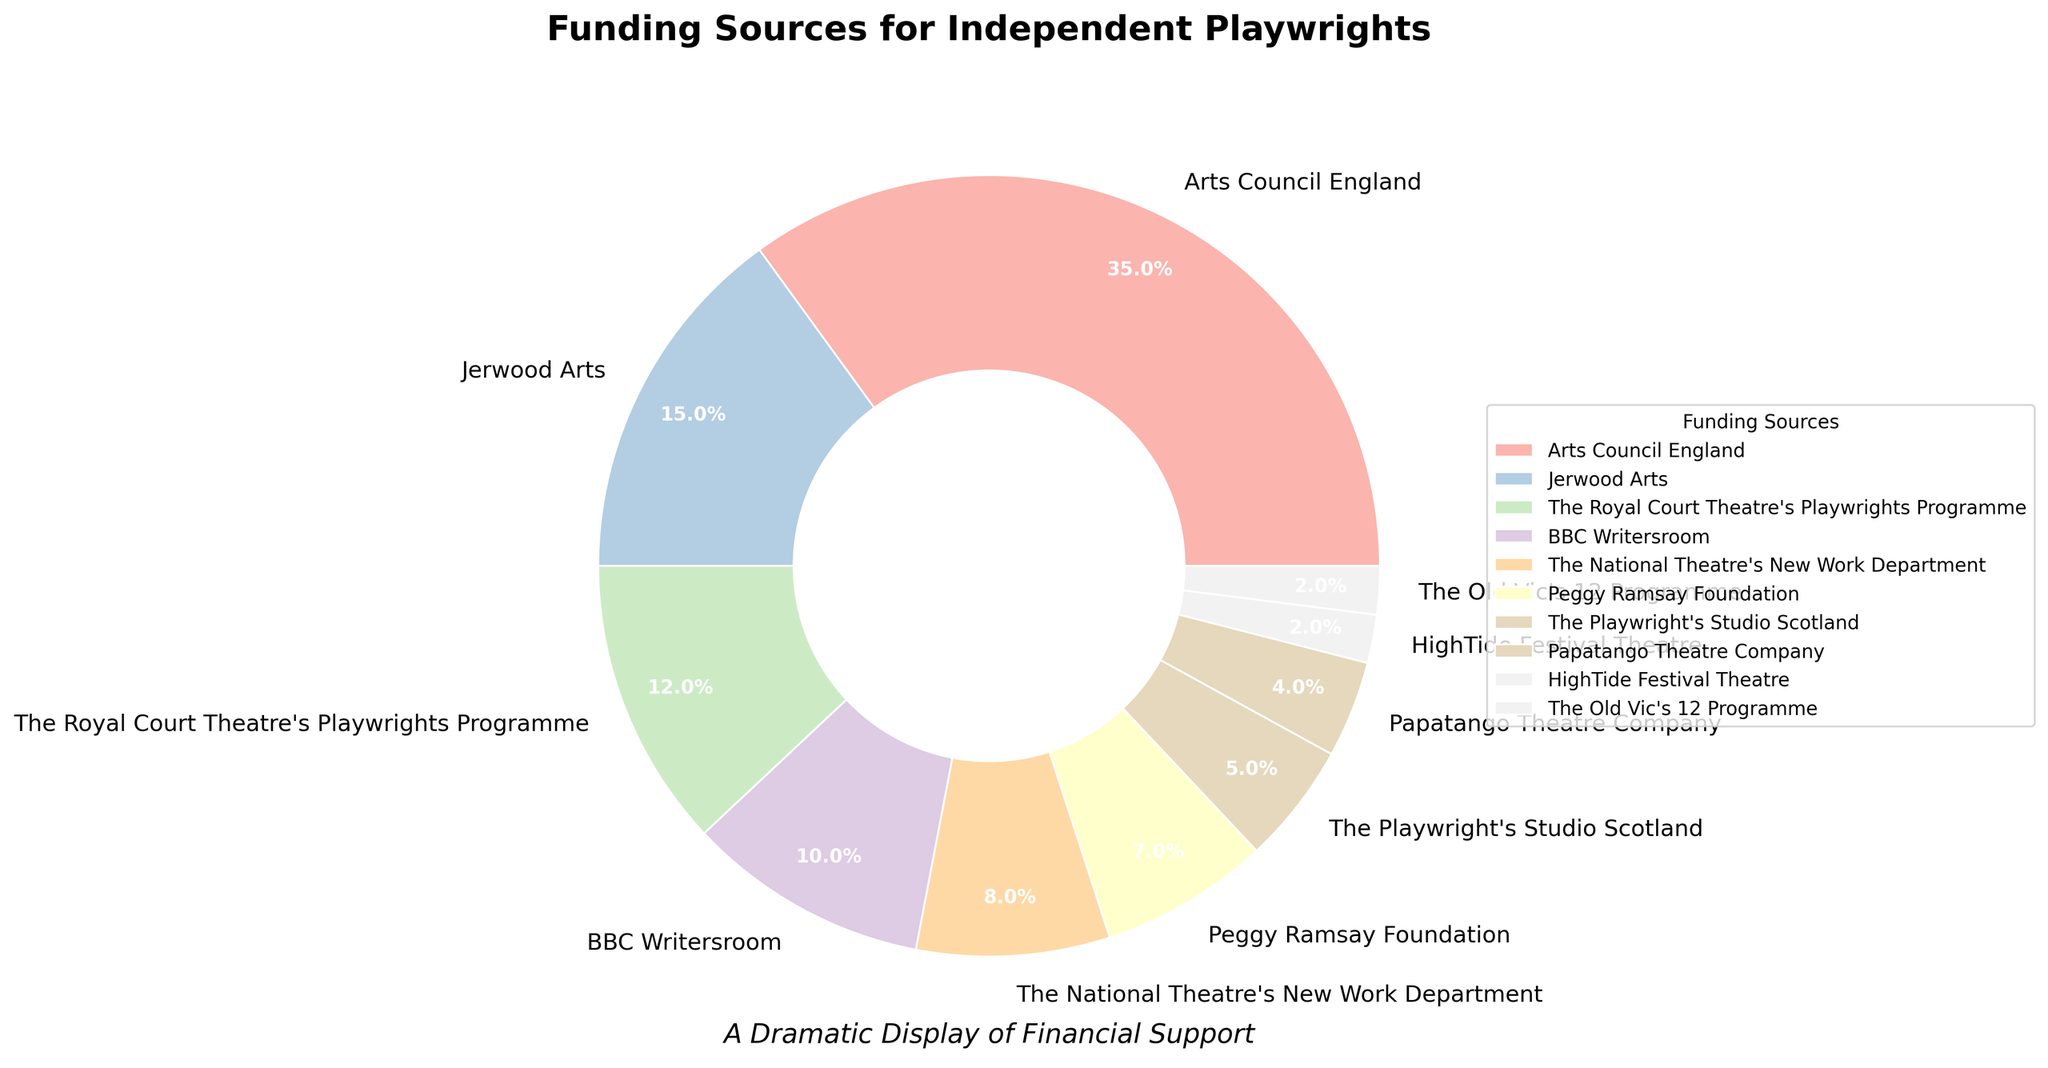What is the largest funding source for independent playwrights? The largest piece of the pie chart represents Arts Council England.
Answer: Arts Council England What percentage of funding is provided by Arts Council England compared to The Royal Court Theatre's Playwrights Programme? According to the chart, Arts Council England provides 35% while The Royal Court Theatre's Playwrights Programme provides 12%. Comparing them gives 35% - 12% = 23%.
Answer: 23% Which funding sources provide less than 5% each? The chart shows that HighTide Festival Theatre (2%), The Old Vic's 12 Programme (2%), and Papatango Theatre Company (4%) all provide less than 5%.
Answer: HighTide Festival Theatre, The Old Vic's 12 Programme, Papatango Theatre Company What is the combined percentage of funding from BBC Writersroom and The National Theatre's New Work Department? BBC Writersroom contributes 10% and The National Theatre's New Work Department contributes 8%. Adding these together gives 10% + 8% = 18%.
Answer: 18% Which funding source has the smallest contribution? The smallest piece of the pie chart represents HighTide Festival Theatre and The Old Vic's 12 Programme, each with 2%.
Answer: HighTide Festival Theatre, The Old Vic's 12 Programme How much more funding does Jerwood Arts provide compared to The Playwright's Studio Scotland? According to the pie chart, Jerwood Arts provides 15% and The Playwright's Studio Scotland provides 5%. The difference is 15% - 5% = 10%.
Answer: 10% What is the total percentage contribution of the top three funding sources? The top three funding sources are Arts Council England (35%), Jerwood Arts (15%), and The Royal Court Theatre's Playwrights Programme (12%). Their combined percentage is 35% + 15% + 12% = 62%.
Answer: 62% Which funding source is represented by a wedge in the most vibrant color? This question relies on visual attributes. According to the color palette from the pie chart using Pastel1, BBC Writersroom often uses a more vibrant color from that palette.
Answer: BBC Writersroom Is the combined funding from Peggy Ramsay Foundation and The Playwright's Studio Scotland more than that of The Royal Court Theatre's Playwrights Programme? Peggy Ramsay Foundation provides 7% and The Playwright's Studio Scotland provides 5%. Their combined percentage is 7% + 5% = 12%, which is equal to The Royal Court Theatre's Playwrights Programme's contribution of 12%.
Answer: No (equal) Do more than half of the funding sources contribute less than 10% each? By reviewing the pie chart, 7 out of 10 funding sources (Jerwood Arts, The Royal Court Theatre's Playwrights Programme, BBC Writersroom, The National Theatre's New Work Department, Peggy Ramsay Foundation, The Playwright's Studio Scotland, Papatango Theatre Company, HighTide Festival Theatre, and The Old Vic's 12 Programme) each contribute less than 10%.
Answer: Yes 